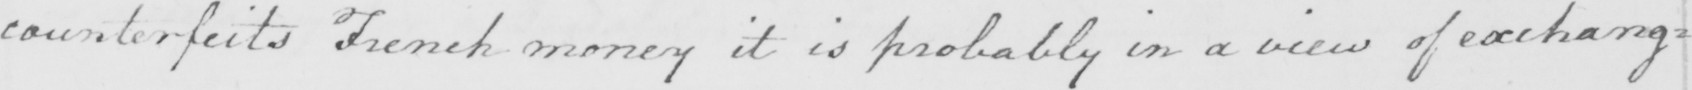Can you tell me what this handwritten text says? counterfeits French money it is probably in a view of exchang= 